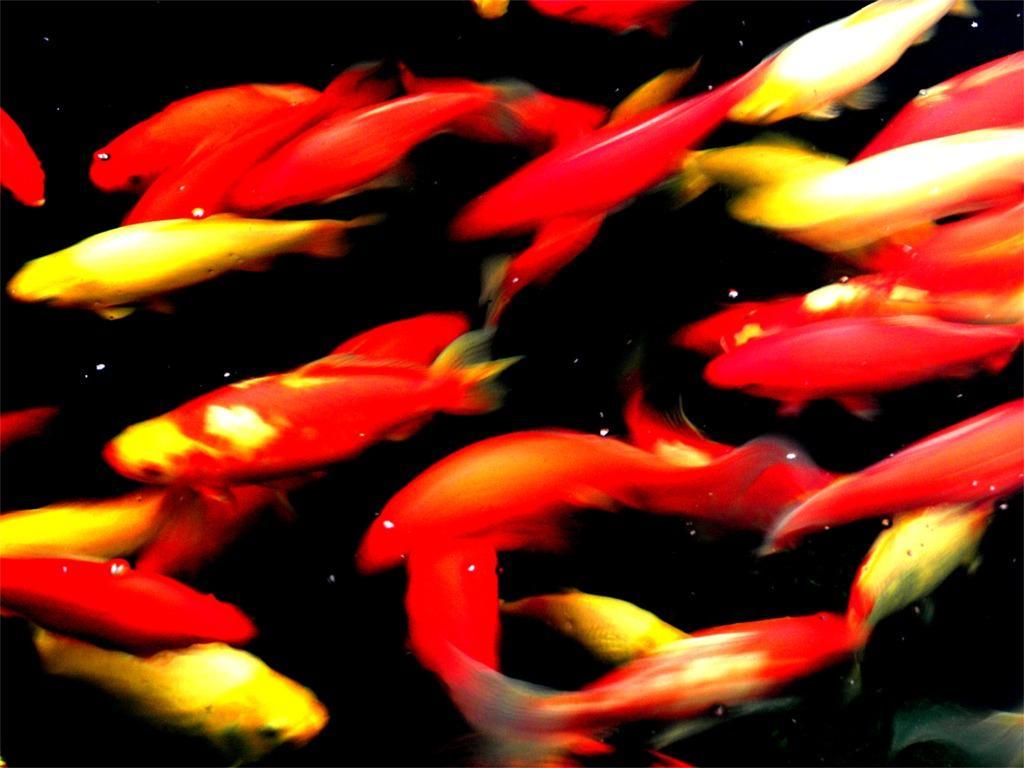Could you give a brief overview of what you see in this image? In this picture there are red and yellow color fishes in the water. 